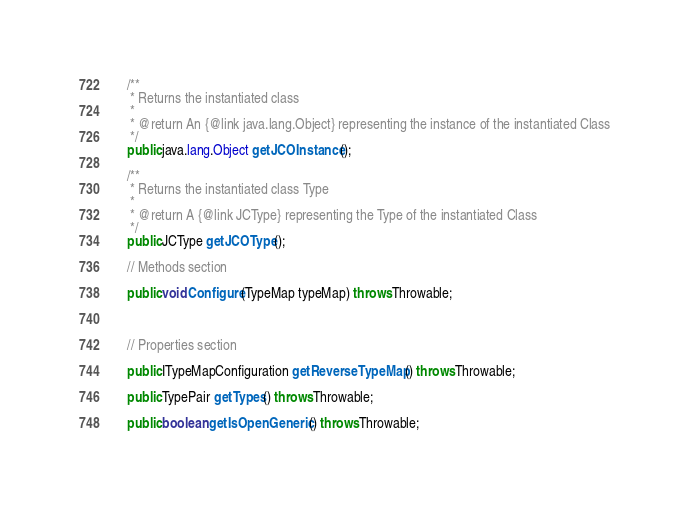Convert code to text. <code><loc_0><loc_0><loc_500><loc_500><_Java_>    /**
     * Returns the instantiated class
     * 
     * @return An {@link java.lang.Object} representing the instance of the instantiated Class
     */
    public java.lang.Object getJCOInstance();

    /**
     * Returns the instantiated class Type
     * 
     * @return A {@link JCType} representing the Type of the instantiated Class
     */
    public JCType getJCOType();

    // Methods section
    
    public void Configure(TypeMap typeMap) throws Throwable;


    
    // Properties section
    
    public ITypeMapConfiguration getReverseTypeMap() throws Throwable;

    public TypePair getTypes() throws Throwable;

    public boolean getIsOpenGeneric() throws Throwable;
</code> 